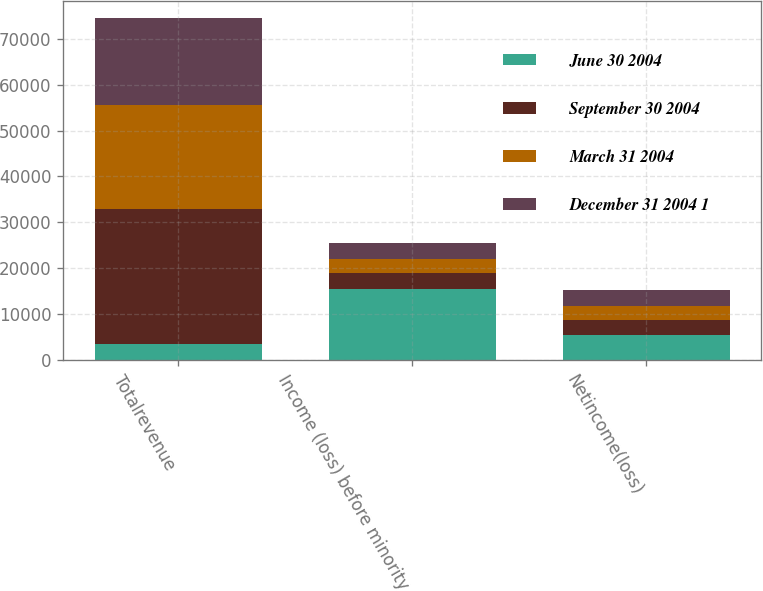Convert chart to OTSL. <chart><loc_0><loc_0><loc_500><loc_500><stacked_bar_chart><ecel><fcel>Totalrevenue<fcel>Income (loss) before minority<fcel>Netincome(loss)<nl><fcel>June 30 2004<fcel>3507<fcel>15569<fcel>5359<nl><fcel>September 30 2004<fcel>29346<fcel>3387<fcel>3359<nl><fcel>March 31 2004<fcel>22800<fcel>2994<fcel>3096<nl><fcel>December 31 2004 1<fcel>18770<fcel>3507<fcel>3461<nl></chart> 